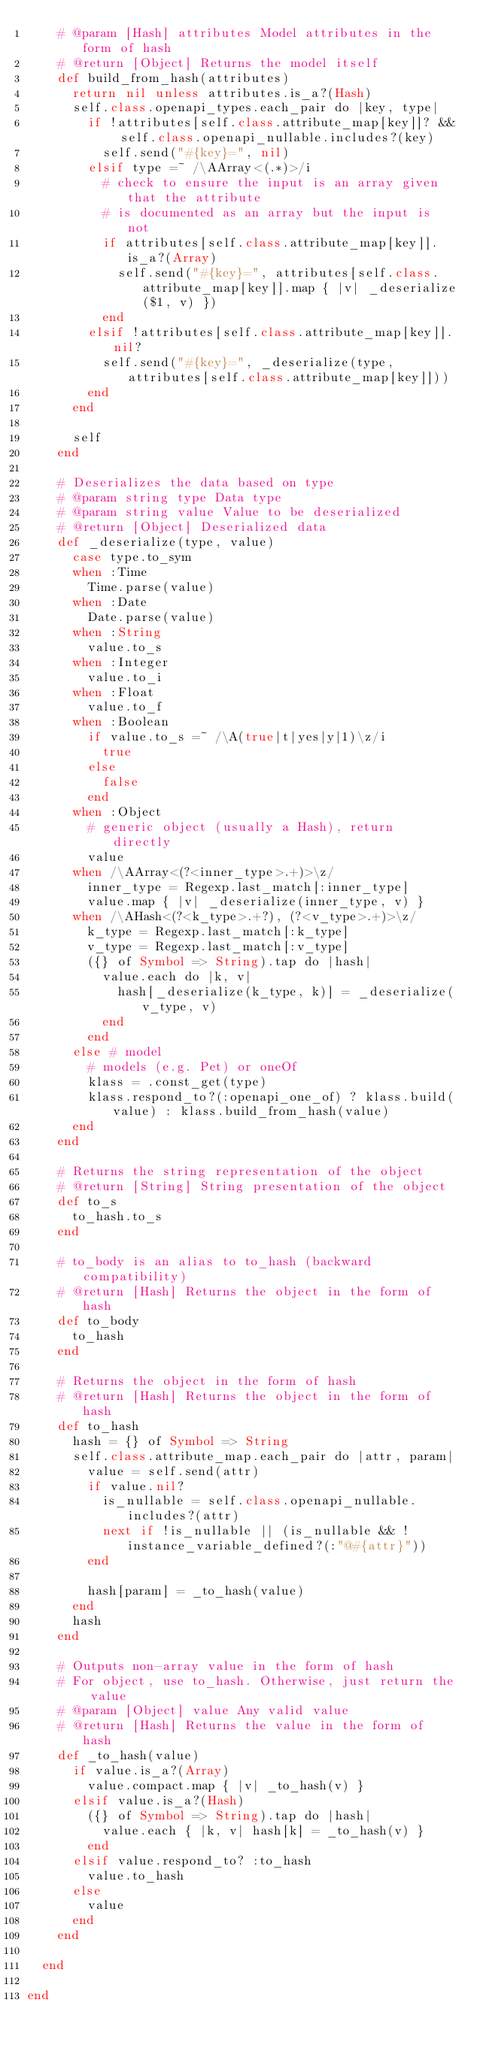<code> <loc_0><loc_0><loc_500><loc_500><_Crystal_>    # @param [Hash] attributes Model attributes in the form of hash
    # @return [Object] Returns the model itself
    def build_from_hash(attributes)
      return nil unless attributes.is_a?(Hash)
      self.class.openapi_types.each_pair do |key, type|
        if !attributes[self.class.attribute_map[key]]? && self.class.openapi_nullable.includes?(key)
          self.send("#{key}=", nil)
        elsif type =~ /\AArray<(.*)>/i
          # check to ensure the input is an array given that the attribute
          # is documented as an array but the input is not
          if attributes[self.class.attribute_map[key]].is_a?(Array)
            self.send("#{key}=", attributes[self.class.attribute_map[key]].map { |v| _deserialize($1, v) })
          end
        elsif !attributes[self.class.attribute_map[key]].nil?
          self.send("#{key}=", _deserialize(type, attributes[self.class.attribute_map[key]]))
        end
      end

      self
    end

    # Deserializes the data based on type
    # @param string type Data type
    # @param string value Value to be deserialized
    # @return [Object] Deserialized data
    def _deserialize(type, value)
      case type.to_sym
      when :Time
        Time.parse(value)
      when :Date
        Date.parse(value)
      when :String
        value.to_s
      when :Integer
        value.to_i
      when :Float
        value.to_f
      when :Boolean
        if value.to_s =~ /\A(true|t|yes|y|1)\z/i
          true
        else
          false
        end
      when :Object
        # generic object (usually a Hash), return directly
        value
      when /\AArray<(?<inner_type>.+)>\z/
        inner_type = Regexp.last_match[:inner_type]
        value.map { |v| _deserialize(inner_type, v) }
      when /\AHash<(?<k_type>.+?), (?<v_type>.+)>\z/
        k_type = Regexp.last_match[:k_type]
        v_type = Regexp.last_match[:v_type]
        ({} of Symbol => String).tap do |hash|
          value.each do |k, v|
            hash[_deserialize(k_type, k)] = _deserialize(v_type, v)
          end
        end
      else # model
        # models (e.g. Pet) or oneOf
        klass = .const_get(type)
        klass.respond_to?(:openapi_one_of) ? klass.build(value) : klass.build_from_hash(value)
      end
    end

    # Returns the string representation of the object
    # @return [String] String presentation of the object
    def to_s
      to_hash.to_s
    end

    # to_body is an alias to to_hash (backward compatibility)
    # @return [Hash] Returns the object in the form of hash
    def to_body
      to_hash
    end

    # Returns the object in the form of hash
    # @return [Hash] Returns the object in the form of hash
    def to_hash
      hash = {} of Symbol => String
      self.class.attribute_map.each_pair do |attr, param|
        value = self.send(attr)
        if value.nil?
          is_nullable = self.class.openapi_nullable.includes?(attr)
          next if !is_nullable || (is_nullable && !instance_variable_defined?(:"@#{attr}"))
        end

        hash[param] = _to_hash(value)
      end
      hash
    end

    # Outputs non-array value in the form of hash
    # For object, use to_hash. Otherwise, just return the value
    # @param [Object] value Any valid value
    # @return [Hash] Returns the value in the form of hash
    def _to_hash(value)
      if value.is_a?(Array)
        value.compact.map { |v| _to_hash(v) }
      elsif value.is_a?(Hash)
        ({} of Symbol => String).tap do |hash|
          value.each { |k, v| hash[k] = _to_hash(v) }
        end
      elsif value.respond_to? :to_hash
        value.to_hash
      else
        value
      end
    end

  end

end
</code> 